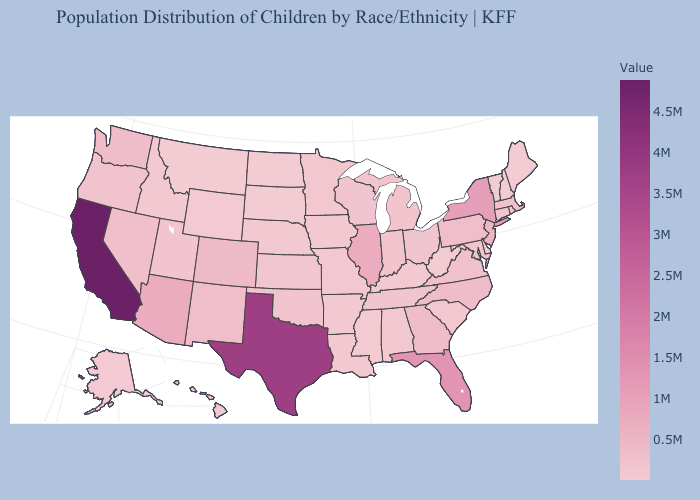Does Vermont have the lowest value in the USA?
Short answer required. Yes. Among the states that border Virginia , does Kentucky have the highest value?
Quick response, please. No. Among the states that border Nebraska , does Iowa have the highest value?
Be succinct. No. Does Michigan have a lower value than Arizona?
Concise answer only. Yes. Among the states that border Idaho , does Oregon have the highest value?
Quick response, please. No. Which states have the lowest value in the USA?
Short answer required. Vermont. 